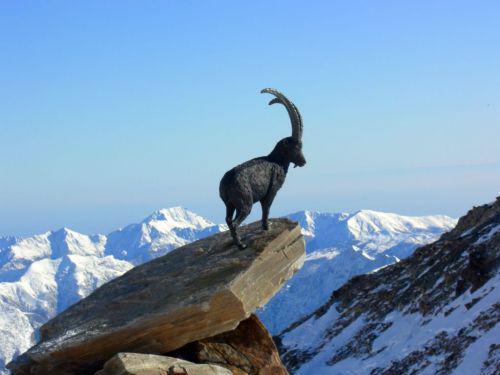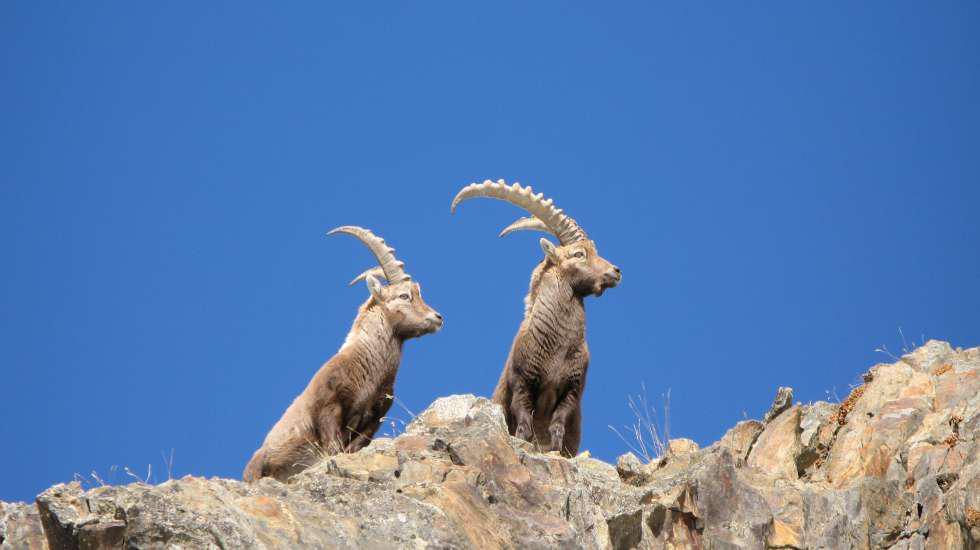The first image is the image on the left, the second image is the image on the right. Given the left and right images, does the statement "The left image shows one horned animal standing on an inclined rock surface." hold true? Answer yes or no. Yes. The first image is the image on the left, the second image is the image on the right. For the images shown, is this caption "All images have a blue background; not a cloud in the sky." true? Answer yes or no. Yes. 